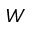<formula> <loc_0><loc_0><loc_500><loc_500>W</formula> 